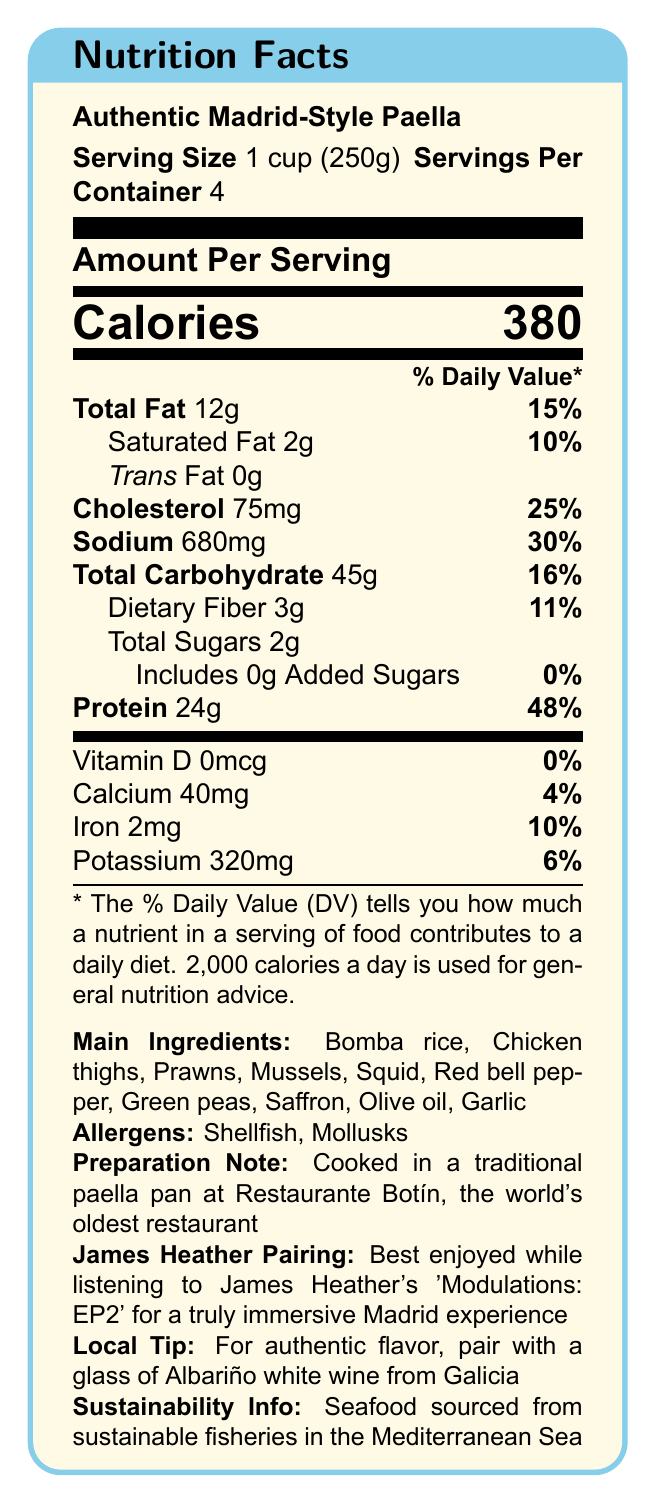what is the serving size? The serving size is clearly stated at the top of the document under the "Serving Size" section.
Answer: 1 cup (250g) how many milligrams of cholesterol are in one serving? The amount of cholesterol per serving is listed as 75 mg under the "Cholesterol" section.
Answer: 75 mg what percent of the daily value is the total fat per serving? The daily value percentage for total fat is given as 15% next to the total fat amount.
Answer: 15% what is the preparation note for the paella? The preparation note is mentioned at the bottom of the document under the "Preparation Note" section.
Answer: Cooked in a traditional paella pan at Restaurante Botín, the world's oldest restaurant name two main ingredients in this paella. The main ingredients are listed towards the bottom of the document under the "Main Ingredients" section.
Answer: Bomba rice, Chicken thighs how many servings are there per container? The number of servings per container is stated right next to the serving size at the top of the document.
Answer: 4 what is the best musical pairing for enjoying this paella? The best musical pairing is mentioned under the "James Heather Pairing" section towards the bottom of the document.
Answer: James Heather's 'Modulations: EP2' which of the following is NOT an allergen in this paella? A. Shellfish B. Mollusks C. Peanuts The allergens listed are Shellfish and Mollusks; Peanuts are not mentioned.
Answer: C. Peanuts what vitamin is not present in this paella? The document states that the amount of Vitamin D is 0 mcg, indicating it is not present.
Answer: Vitamin D how much protein is in one serving of paella? The protein content per serving is listed as 24g under the "Protein" section.
Answer: 24g which wine is recommended to pair with this paella? A. Albariño white wine B. Rioja red wine C. Cava sparkling wine The recommended wine pairing is mentioned under the "Local Tip" section.
Answer: A. Albariño white wine is the seafood in this paella sustainably sourced? (Yes/No) The document states that the seafood is sourced from sustainable fisheries in the Mediterranean Sea under the "Sustainability Info" section.
Answer: Yes summarize the key nutritional features of the Madrid-Style Paella. The summary includes the calorie content, macro nutrients like fat, cholesterol, sodium, carbohydrates, and protein, emphasizing the high protein content and listing some of the main ingredients.
Answer: The Authentic Madrid-Style Paella has 380 calories per serving, with 12g of total fat, 75mg of cholesterol, 680mg of sodium, 45g of carbohydrates, and 24g of protein. It is rich in protein, providing 48% of the daily value, and contains ingredients like Bomba rice, chicken thighs, and seafood. what is the source of the saffron used in this paella? The document does not provide any information on the source of the saffron used in the paella.
Answer: Not enough information 